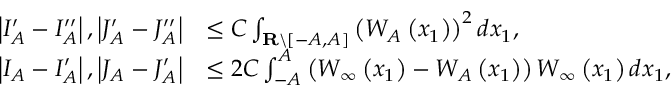<formula> <loc_0><loc_0><loc_500><loc_500>\begin{array} { r l } { \left | I _ { A } ^ { \prime } - I _ { A } ^ { \prime \prime } \right | , \left | J _ { A } ^ { \prime } - J _ { A } ^ { \prime \prime } \right | } & { \leq C \int _ { R \ [ - A , A ] } \left ( W _ { A } \left ( x _ { 1 } \right ) \right ) ^ { 2 } d x _ { 1 } , } \\ { \left | I _ { A } - I _ { A } ^ { \prime } \right | , \left | J _ { A } - J _ { A } ^ { \prime } \right | } & { \leq 2 C \int _ { - A } ^ { A } \left ( W _ { \infty } \left ( x _ { 1 } \right ) - W _ { A } \left ( x _ { 1 } \right ) \right ) W _ { \infty } \left ( x _ { 1 } \right ) d x _ { 1 } , } \end{array}</formula> 